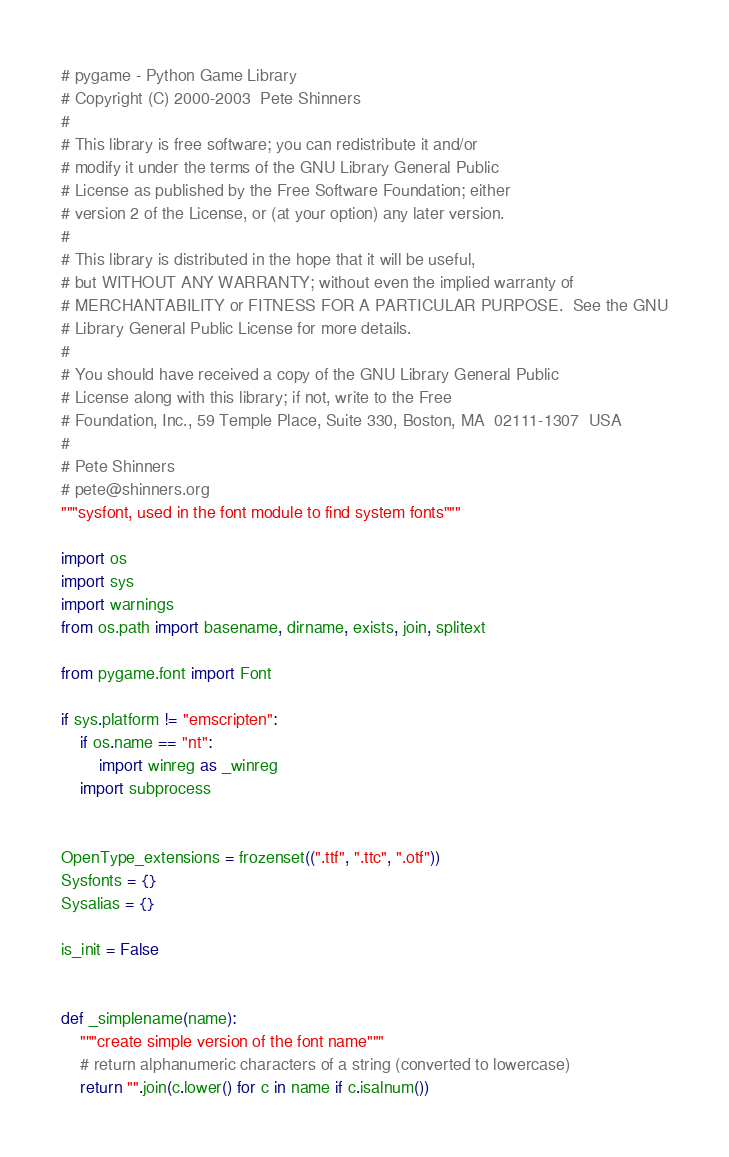<code> <loc_0><loc_0><loc_500><loc_500><_Python_># pygame - Python Game Library
# Copyright (C) 2000-2003  Pete Shinners
#
# This library is free software; you can redistribute it and/or
# modify it under the terms of the GNU Library General Public
# License as published by the Free Software Foundation; either
# version 2 of the License, or (at your option) any later version.
#
# This library is distributed in the hope that it will be useful,
# but WITHOUT ANY WARRANTY; without even the implied warranty of
# MERCHANTABILITY or FITNESS FOR A PARTICULAR PURPOSE.  See the GNU
# Library General Public License for more details.
#
# You should have received a copy of the GNU Library General Public
# License along with this library; if not, write to the Free
# Foundation, Inc., 59 Temple Place, Suite 330, Boston, MA  02111-1307  USA
#
# Pete Shinners
# pete@shinners.org
"""sysfont, used in the font module to find system fonts"""

import os
import sys
import warnings
from os.path import basename, dirname, exists, join, splitext

from pygame.font import Font

if sys.platform != "emscripten":
    if os.name == "nt":
        import winreg as _winreg
    import subprocess


OpenType_extensions = frozenset((".ttf", ".ttc", ".otf"))
Sysfonts = {}
Sysalias = {}

is_init = False


def _simplename(name):
    """create simple version of the font name"""
    # return alphanumeric characters of a string (converted to lowercase)
    return "".join(c.lower() for c in name if c.isalnum())

</code> 